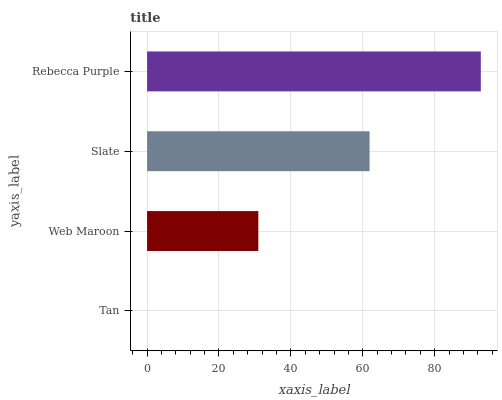Is Tan the minimum?
Answer yes or no. Yes. Is Rebecca Purple the maximum?
Answer yes or no. Yes. Is Web Maroon the minimum?
Answer yes or no. No. Is Web Maroon the maximum?
Answer yes or no. No. Is Web Maroon greater than Tan?
Answer yes or no. Yes. Is Tan less than Web Maroon?
Answer yes or no. Yes. Is Tan greater than Web Maroon?
Answer yes or no. No. Is Web Maroon less than Tan?
Answer yes or no. No. Is Slate the high median?
Answer yes or no. Yes. Is Web Maroon the low median?
Answer yes or no. Yes. Is Rebecca Purple the high median?
Answer yes or no. No. Is Rebecca Purple the low median?
Answer yes or no. No. 